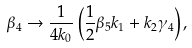Convert formula to latex. <formula><loc_0><loc_0><loc_500><loc_500>\beta _ { 4 } \rightarrow \frac { 1 } { 4 k _ { 0 } } \left ( \frac { 1 } { 2 } \beta _ { 5 } k _ { 1 } + k _ { 2 } \gamma _ { 4 } \right ) ,</formula> 